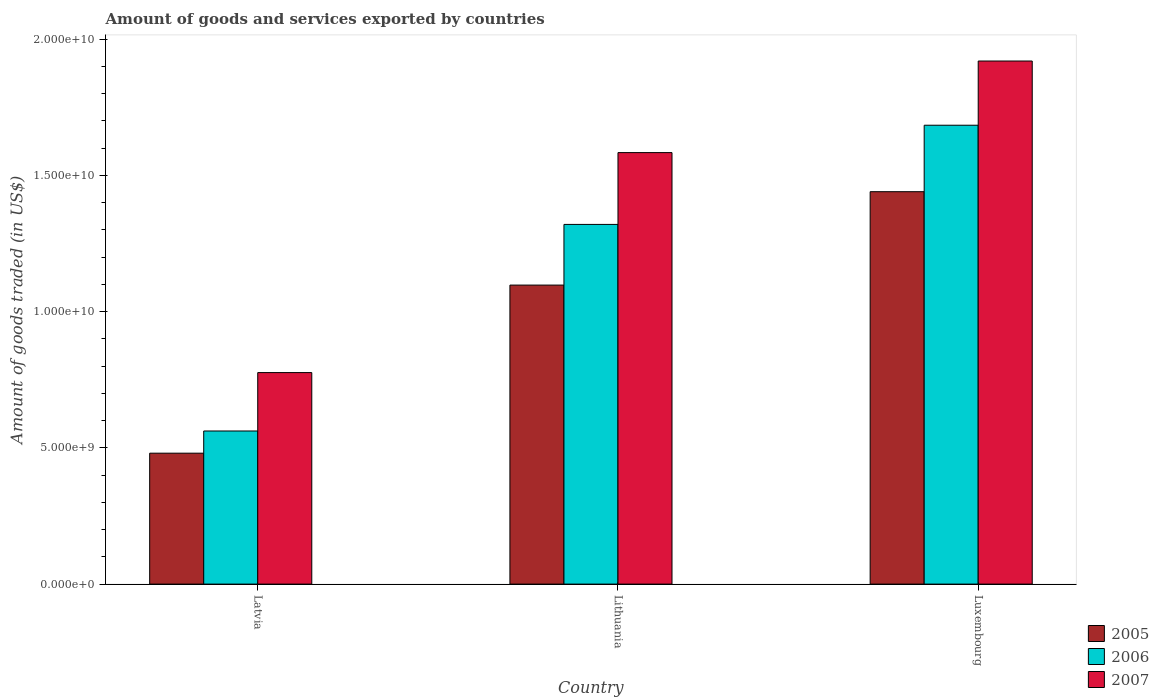How many groups of bars are there?
Your answer should be compact. 3. Are the number of bars per tick equal to the number of legend labels?
Give a very brief answer. Yes. What is the label of the 2nd group of bars from the left?
Your response must be concise. Lithuania. In how many cases, is the number of bars for a given country not equal to the number of legend labels?
Provide a short and direct response. 0. What is the total amount of goods and services exported in 2006 in Latvia?
Your answer should be very brief. 5.62e+09. Across all countries, what is the maximum total amount of goods and services exported in 2005?
Provide a short and direct response. 1.44e+1. Across all countries, what is the minimum total amount of goods and services exported in 2007?
Ensure brevity in your answer.  7.76e+09. In which country was the total amount of goods and services exported in 2006 maximum?
Make the answer very short. Luxembourg. In which country was the total amount of goods and services exported in 2005 minimum?
Your answer should be compact. Latvia. What is the total total amount of goods and services exported in 2007 in the graph?
Ensure brevity in your answer.  4.28e+1. What is the difference between the total amount of goods and services exported in 2007 in Latvia and that in Luxembourg?
Offer a terse response. -1.14e+1. What is the difference between the total amount of goods and services exported in 2007 in Lithuania and the total amount of goods and services exported in 2005 in Latvia?
Offer a very short reply. 1.10e+1. What is the average total amount of goods and services exported in 2005 per country?
Your answer should be compact. 1.01e+1. What is the difference between the total amount of goods and services exported of/in 2005 and total amount of goods and services exported of/in 2006 in Lithuania?
Keep it short and to the point. -2.23e+09. In how many countries, is the total amount of goods and services exported in 2006 greater than 5000000000 US$?
Your response must be concise. 3. What is the ratio of the total amount of goods and services exported in 2007 in Latvia to that in Lithuania?
Your answer should be very brief. 0.49. Is the difference between the total amount of goods and services exported in 2005 in Latvia and Luxembourg greater than the difference between the total amount of goods and services exported in 2006 in Latvia and Luxembourg?
Offer a terse response. Yes. What is the difference between the highest and the second highest total amount of goods and services exported in 2005?
Give a very brief answer. -9.60e+09. What is the difference between the highest and the lowest total amount of goods and services exported in 2005?
Keep it short and to the point. 9.60e+09. Is the sum of the total amount of goods and services exported in 2005 in Latvia and Luxembourg greater than the maximum total amount of goods and services exported in 2007 across all countries?
Keep it short and to the point. Yes. What does the 2nd bar from the left in Lithuania represents?
Ensure brevity in your answer.  2006. What does the 2nd bar from the right in Lithuania represents?
Offer a very short reply. 2006. Is it the case that in every country, the sum of the total amount of goods and services exported in 2007 and total amount of goods and services exported in 2005 is greater than the total amount of goods and services exported in 2006?
Your response must be concise. Yes. Are all the bars in the graph horizontal?
Your response must be concise. No. How many countries are there in the graph?
Provide a succinct answer. 3. Does the graph contain any zero values?
Provide a short and direct response. No. Where does the legend appear in the graph?
Your answer should be compact. Bottom right. How many legend labels are there?
Provide a short and direct response. 3. How are the legend labels stacked?
Keep it short and to the point. Vertical. What is the title of the graph?
Provide a succinct answer. Amount of goods and services exported by countries. What is the label or title of the X-axis?
Your response must be concise. Country. What is the label or title of the Y-axis?
Give a very brief answer. Amount of goods traded (in US$). What is the Amount of goods traded (in US$) in 2005 in Latvia?
Keep it short and to the point. 4.80e+09. What is the Amount of goods traded (in US$) of 2006 in Latvia?
Your response must be concise. 5.62e+09. What is the Amount of goods traded (in US$) of 2007 in Latvia?
Keep it short and to the point. 7.76e+09. What is the Amount of goods traded (in US$) in 2005 in Lithuania?
Your answer should be very brief. 1.10e+1. What is the Amount of goods traded (in US$) of 2006 in Lithuania?
Your response must be concise. 1.32e+1. What is the Amount of goods traded (in US$) in 2007 in Lithuania?
Offer a terse response. 1.58e+1. What is the Amount of goods traded (in US$) of 2005 in Luxembourg?
Make the answer very short. 1.44e+1. What is the Amount of goods traded (in US$) of 2006 in Luxembourg?
Keep it short and to the point. 1.68e+1. What is the Amount of goods traded (in US$) in 2007 in Luxembourg?
Provide a short and direct response. 1.92e+1. Across all countries, what is the maximum Amount of goods traded (in US$) of 2005?
Your response must be concise. 1.44e+1. Across all countries, what is the maximum Amount of goods traded (in US$) of 2006?
Your response must be concise. 1.68e+1. Across all countries, what is the maximum Amount of goods traded (in US$) in 2007?
Provide a short and direct response. 1.92e+1. Across all countries, what is the minimum Amount of goods traded (in US$) in 2005?
Your answer should be very brief. 4.80e+09. Across all countries, what is the minimum Amount of goods traded (in US$) in 2006?
Your answer should be very brief. 5.62e+09. Across all countries, what is the minimum Amount of goods traded (in US$) in 2007?
Provide a succinct answer. 7.76e+09. What is the total Amount of goods traded (in US$) in 2005 in the graph?
Keep it short and to the point. 3.02e+1. What is the total Amount of goods traded (in US$) in 2006 in the graph?
Offer a very short reply. 3.57e+1. What is the total Amount of goods traded (in US$) of 2007 in the graph?
Provide a succinct answer. 4.28e+1. What is the difference between the Amount of goods traded (in US$) in 2005 in Latvia and that in Lithuania?
Your answer should be very brief. -6.17e+09. What is the difference between the Amount of goods traded (in US$) of 2006 in Latvia and that in Lithuania?
Make the answer very short. -7.58e+09. What is the difference between the Amount of goods traded (in US$) of 2007 in Latvia and that in Lithuania?
Keep it short and to the point. -8.07e+09. What is the difference between the Amount of goods traded (in US$) in 2005 in Latvia and that in Luxembourg?
Provide a succinct answer. -9.60e+09. What is the difference between the Amount of goods traded (in US$) of 2006 in Latvia and that in Luxembourg?
Make the answer very short. -1.12e+1. What is the difference between the Amount of goods traded (in US$) of 2007 in Latvia and that in Luxembourg?
Your response must be concise. -1.14e+1. What is the difference between the Amount of goods traded (in US$) of 2005 in Lithuania and that in Luxembourg?
Your answer should be very brief. -3.43e+09. What is the difference between the Amount of goods traded (in US$) in 2006 in Lithuania and that in Luxembourg?
Give a very brief answer. -3.64e+09. What is the difference between the Amount of goods traded (in US$) in 2007 in Lithuania and that in Luxembourg?
Offer a terse response. -3.36e+09. What is the difference between the Amount of goods traded (in US$) of 2005 in Latvia and the Amount of goods traded (in US$) of 2006 in Lithuania?
Your response must be concise. -8.40e+09. What is the difference between the Amount of goods traded (in US$) in 2005 in Latvia and the Amount of goods traded (in US$) in 2007 in Lithuania?
Ensure brevity in your answer.  -1.10e+1. What is the difference between the Amount of goods traded (in US$) of 2006 in Latvia and the Amount of goods traded (in US$) of 2007 in Lithuania?
Give a very brief answer. -1.02e+1. What is the difference between the Amount of goods traded (in US$) in 2005 in Latvia and the Amount of goods traded (in US$) in 2006 in Luxembourg?
Provide a succinct answer. -1.20e+1. What is the difference between the Amount of goods traded (in US$) of 2005 in Latvia and the Amount of goods traded (in US$) of 2007 in Luxembourg?
Provide a short and direct response. -1.44e+1. What is the difference between the Amount of goods traded (in US$) of 2006 in Latvia and the Amount of goods traded (in US$) of 2007 in Luxembourg?
Your answer should be very brief. -1.36e+1. What is the difference between the Amount of goods traded (in US$) in 2005 in Lithuania and the Amount of goods traded (in US$) in 2006 in Luxembourg?
Offer a very short reply. -5.87e+09. What is the difference between the Amount of goods traded (in US$) in 2005 in Lithuania and the Amount of goods traded (in US$) in 2007 in Luxembourg?
Make the answer very short. -8.22e+09. What is the difference between the Amount of goods traded (in US$) in 2006 in Lithuania and the Amount of goods traded (in US$) in 2007 in Luxembourg?
Provide a short and direct response. -6.00e+09. What is the average Amount of goods traded (in US$) in 2005 per country?
Offer a very short reply. 1.01e+1. What is the average Amount of goods traded (in US$) in 2006 per country?
Ensure brevity in your answer.  1.19e+1. What is the average Amount of goods traded (in US$) of 2007 per country?
Your response must be concise. 1.43e+1. What is the difference between the Amount of goods traded (in US$) of 2005 and Amount of goods traded (in US$) of 2006 in Latvia?
Your response must be concise. -8.14e+08. What is the difference between the Amount of goods traded (in US$) of 2005 and Amount of goods traded (in US$) of 2007 in Latvia?
Provide a succinct answer. -2.96e+09. What is the difference between the Amount of goods traded (in US$) in 2006 and Amount of goods traded (in US$) in 2007 in Latvia?
Ensure brevity in your answer.  -2.14e+09. What is the difference between the Amount of goods traded (in US$) of 2005 and Amount of goods traded (in US$) of 2006 in Lithuania?
Your answer should be compact. -2.23e+09. What is the difference between the Amount of goods traded (in US$) in 2005 and Amount of goods traded (in US$) in 2007 in Lithuania?
Make the answer very short. -4.86e+09. What is the difference between the Amount of goods traded (in US$) in 2006 and Amount of goods traded (in US$) in 2007 in Lithuania?
Your response must be concise. -2.64e+09. What is the difference between the Amount of goods traded (in US$) of 2005 and Amount of goods traded (in US$) of 2006 in Luxembourg?
Provide a short and direct response. -2.44e+09. What is the difference between the Amount of goods traded (in US$) of 2005 and Amount of goods traded (in US$) of 2007 in Luxembourg?
Keep it short and to the point. -4.80e+09. What is the difference between the Amount of goods traded (in US$) in 2006 and Amount of goods traded (in US$) in 2007 in Luxembourg?
Keep it short and to the point. -2.36e+09. What is the ratio of the Amount of goods traded (in US$) in 2005 in Latvia to that in Lithuania?
Your answer should be compact. 0.44. What is the ratio of the Amount of goods traded (in US$) of 2006 in Latvia to that in Lithuania?
Keep it short and to the point. 0.43. What is the ratio of the Amount of goods traded (in US$) in 2007 in Latvia to that in Lithuania?
Keep it short and to the point. 0.49. What is the ratio of the Amount of goods traded (in US$) in 2005 in Latvia to that in Luxembourg?
Ensure brevity in your answer.  0.33. What is the ratio of the Amount of goods traded (in US$) in 2006 in Latvia to that in Luxembourg?
Your response must be concise. 0.33. What is the ratio of the Amount of goods traded (in US$) of 2007 in Latvia to that in Luxembourg?
Give a very brief answer. 0.4. What is the ratio of the Amount of goods traded (in US$) of 2005 in Lithuania to that in Luxembourg?
Your answer should be compact. 0.76. What is the ratio of the Amount of goods traded (in US$) of 2006 in Lithuania to that in Luxembourg?
Provide a short and direct response. 0.78. What is the ratio of the Amount of goods traded (in US$) in 2007 in Lithuania to that in Luxembourg?
Your response must be concise. 0.82. What is the difference between the highest and the second highest Amount of goods traded (in US$) of 2005?
Ensure brevity in your answer.  3.43e+09. What is the difference between the highest and the second highest Amount of goods traded (in US$) of 2006?
Provide a succinct answer. 3.64e+09. What is the difference between the highest and the second highest Amount of goods traded (in US$) of 2007?
Provide a short and direct response. 3.36e+09. What is the difference between the highest and the lowest Amount of goods traded (in US$) of 2005?
Your answer should be compact. 9.60e+09. What is the difference between the highest and the lowest Amount of goods traded (in US$) of 2006?
Make the answer very short. 1.12e+1. What is the difference between the highest and the lowest Amount of goods traded (in US$) in 2007?
Provide a short and direct response. 1.14e+1. 